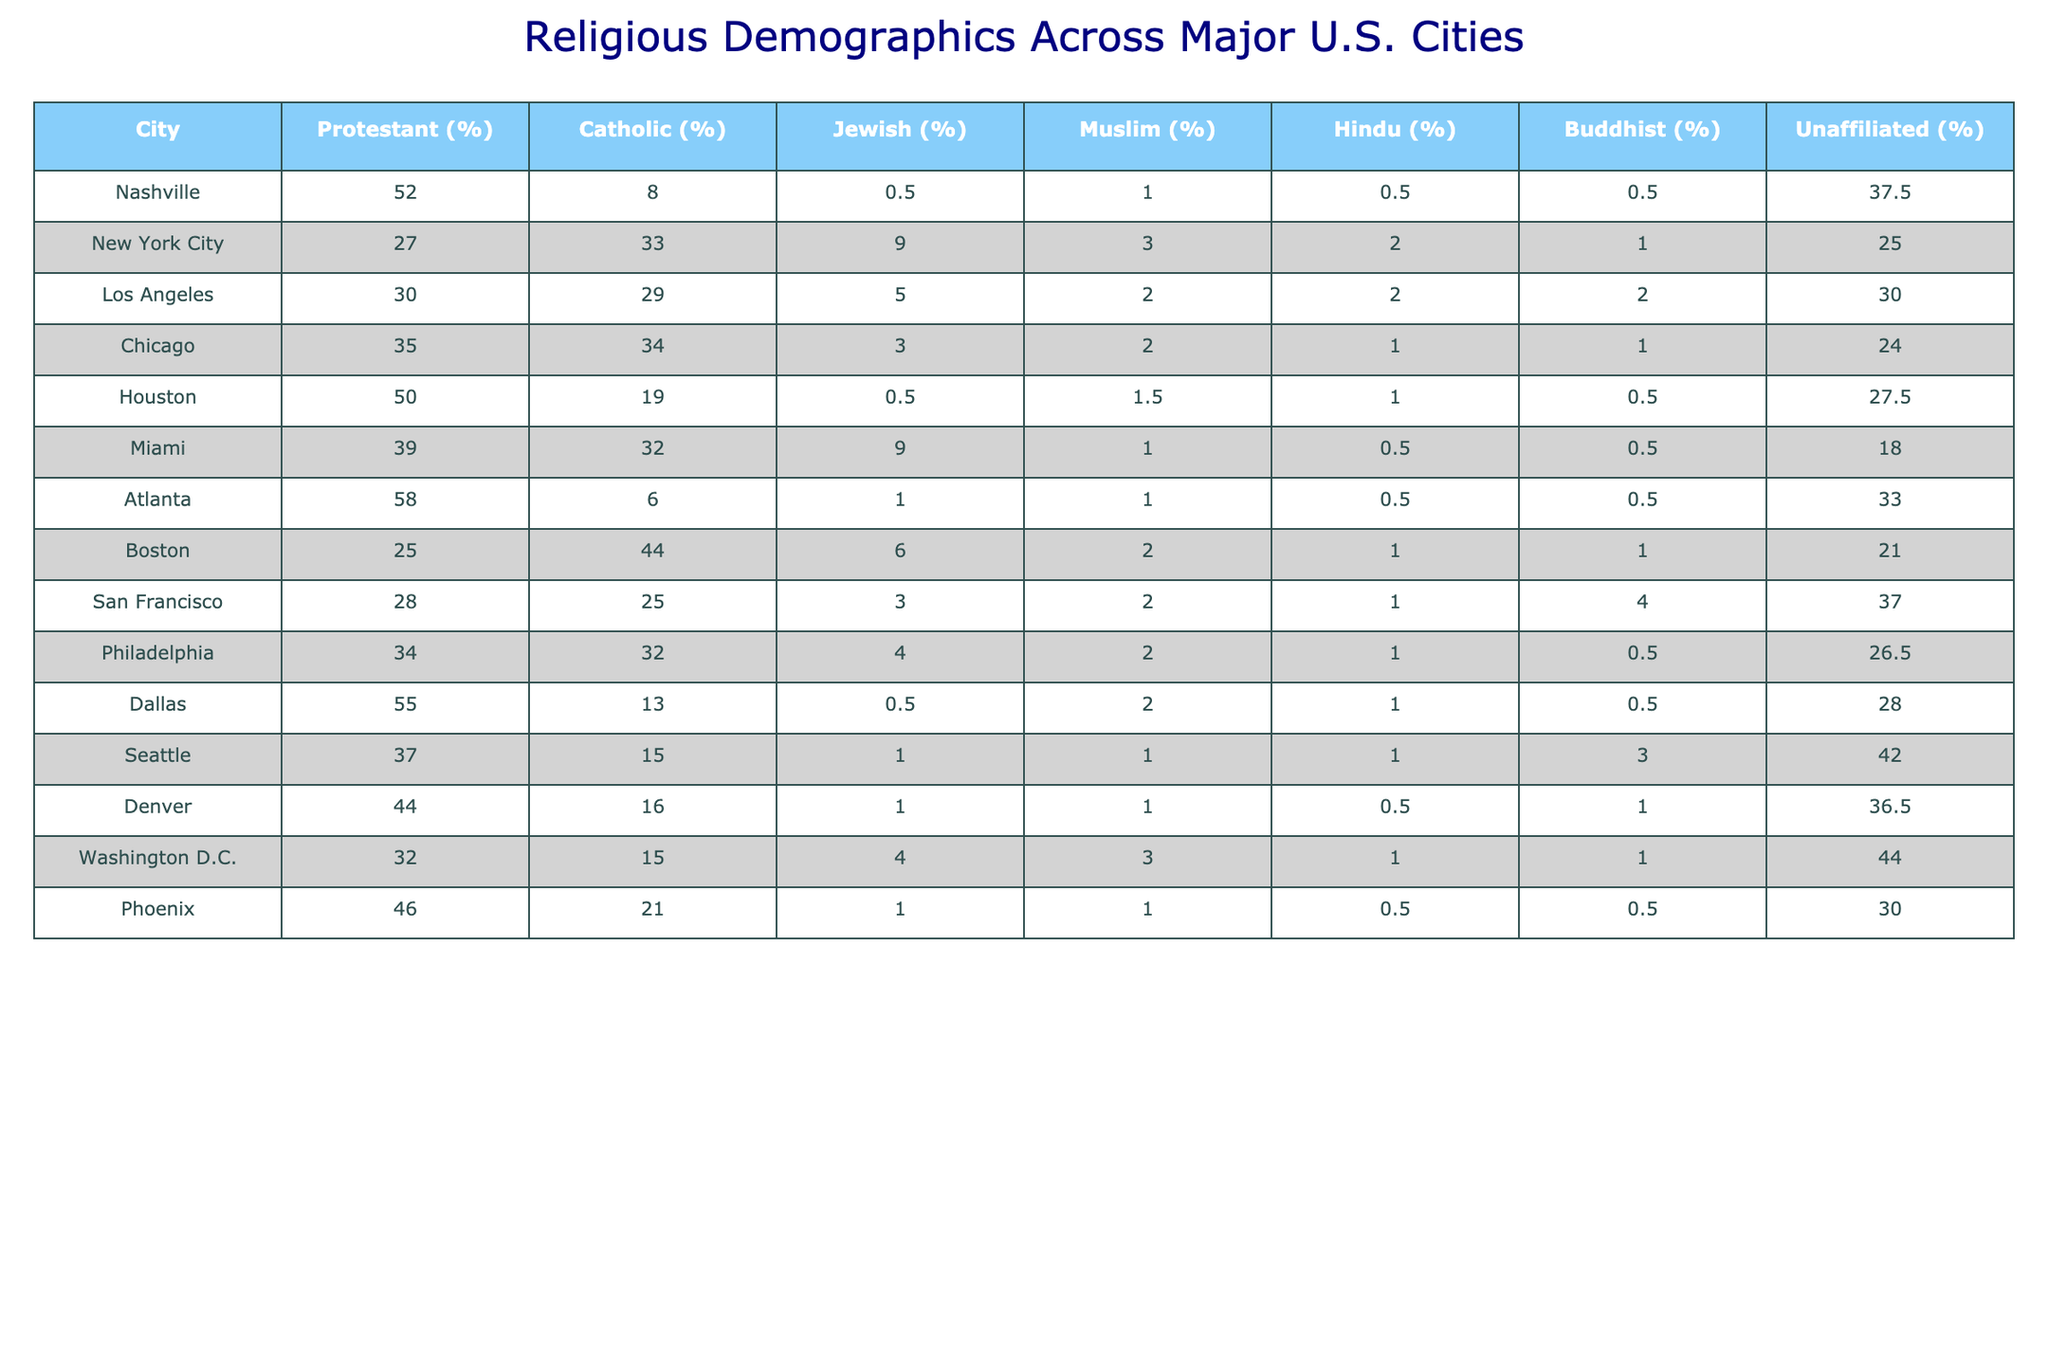What city has the highest percentage of Protestant population? Looking at the table, Atlanta has the highest percentage of Protestants at 58%.
Answer: Atlanta Which city has the lowest percentage of Jewish population? Reviewing the table, Nashville shows the lowest percentage of Jewish population at 0.5%.
Answer: Nashville Is the percentage of unaffiliated individuals higher in Seattle or in Boston? In Seattle, the percentage of unaffiliated individuals is 42%, while in Boston it is 21%. Thus, Seattle has a higher percentage.
Answer: Seattle What is the average percentage of Catholic population across these cities? Adding up the Catholic percentages (8 + 33 + 29 + 34 + 19 + 32 + 6 + 25 + 32 + 13 + 15 + 21) gives  25.75%. Dividing by 12 cities, the average is 25.75%.
Answer: 25.75% How many cities have a Muslim population greater than 2%? From the table, the cities with more than 2% Muslim population are New York City, Houston, and Washington D.C., which totals to 3 cities.
Answer: 3 Does Miami have a higher percentage of Jewish population than Los Angeles? Comparing Miami's Jewish population at 9% and Los Angeles's at 5%, Miami indeed has a higher percentage.
Answer: Yes Which city has a larger proportion of Buddhists: Dallas or Houston? The table shows Dallas with 0.5% of Buddhists and Houston with 1%. Thus, Houston has a larger proportion of Buddhists.
Answer: Houston What is the difference in percentage of unaffiliated population between Seattle and Denver? Seattle's unaffiliated percentage is 42%, while Denver's is 36.5%. The difference is 42% - 36.5% = 5.5%.
Answer: 5.5% In how many cities does the Protestant population make up more than half? Examining the table, only Nashville and Atlanta have a Protestant population greater than 50%, leading to a total of 2 cities.
Answer: 2 What percentage of New York City's population is either Jewish or Muslim? Adding New York City's Jewish population (9%) and Muslim population (3%) gives us 9% + 3% = 12%.
Answer: 12% 